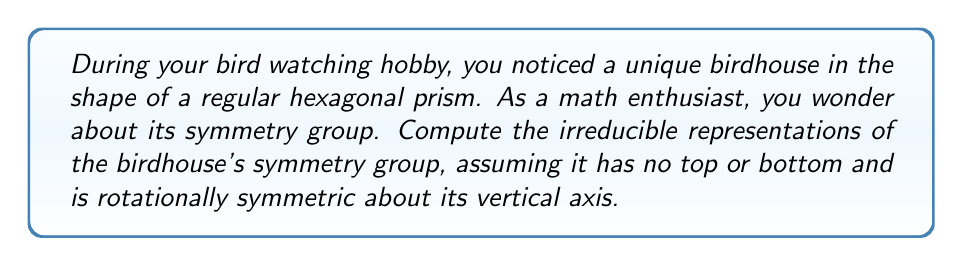Solve this math problem. Let's approach this step-by-step:

1) The symmetry group of a hexagonal prism without top and bottom is $D_{6h}$, which is isomorphic to $D_6 \times C_2$.

2) $D_6$ has order 12 and $C_2$ has order 2, so $D_{6h}$ has order 24.

3) The number of irreducible representations is equal to the number of conjugacy classes. For $D_{6h}$, there are 12 conjugacy classes.

4) We can decompose the representations of $D_{6h}$ using the direct product of representations of $D_6$ and $C_2$.

5) $D_6$ has 6 irreducible representations:
   - Two 1-dimensional: $A_1$, $A_2$
   - Two 1-dimensional: $B_1$, $B_2$
   - Two 2-dimensional: $E_1$, $E_2$

6) $C_2$ has 2 irreducible representations:
   - Two 1-dimensional: $A_g$, $A_u$

7) The irreducible representations of $D_{6h}$ are obtained by taking all possible products of the irreducible representations of $D_6$ and $C_2$:

   $A_1 \otimes A_g$, $A_1 \otimes A_u$
   $A_2 \otimes A_g$, $A_2 \otimes A_u$
   $B_1 \otimes A_g$, $B_1 \otimes A_u$
   $B_2 \otimes A_g$, $B_2 \otimes A_u$
   $E_1 \otimes A_g$, $E_1 \otimes A_u$
   $E_2 \otimes A_g$, $E_2 \otimes A_u$

8) The dimensions of these representations are:
   - 8 one-dimensional representations
   - 4 two-dimensional representations

Thus, we have found all 12 irreducible representations of $D_{6h}$.
Answer: 8 one-dimensional and 4 two-dimensional irreducible representations 